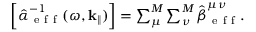<formula> <loc_0><loc_0><loc_500><loc_500>\begin{array} { r } { \left [ \hat { \alpha } _ { e f f } ^ { - 1 } ( \omega , k _ { \| } ) \right ] = \sum _ { \mu } ^ { M } \sum _ { \nu } ^ { M } \hat { \beta } _ { e f f } ^ { \mu \nu } . } \end{array}</formula> 